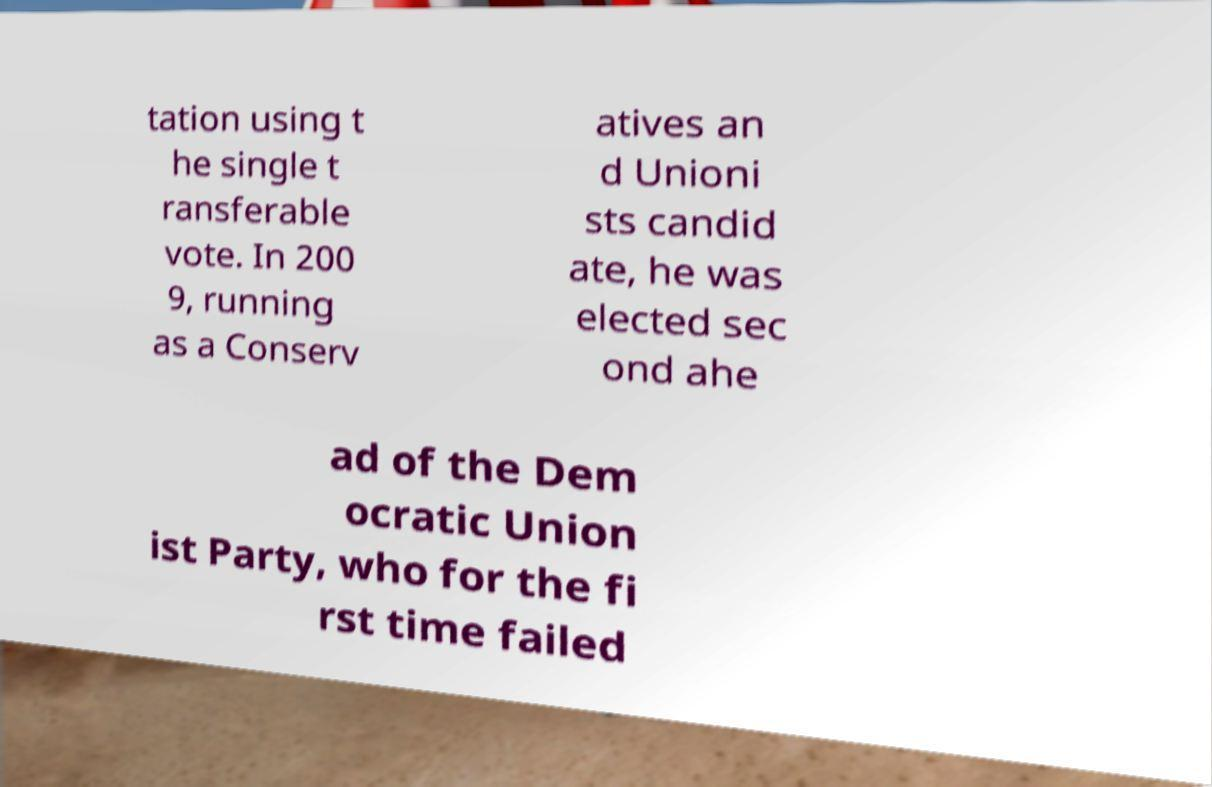Please identify and transcribe the text found in this image. tation using t he single t ransferable vote. In 200 9, running as a Conserv atives an d Unioni sts candid ate, he was elected sec ond ahe ad of the Dem ocratic Union ist Party, who for the fi rst time failed 